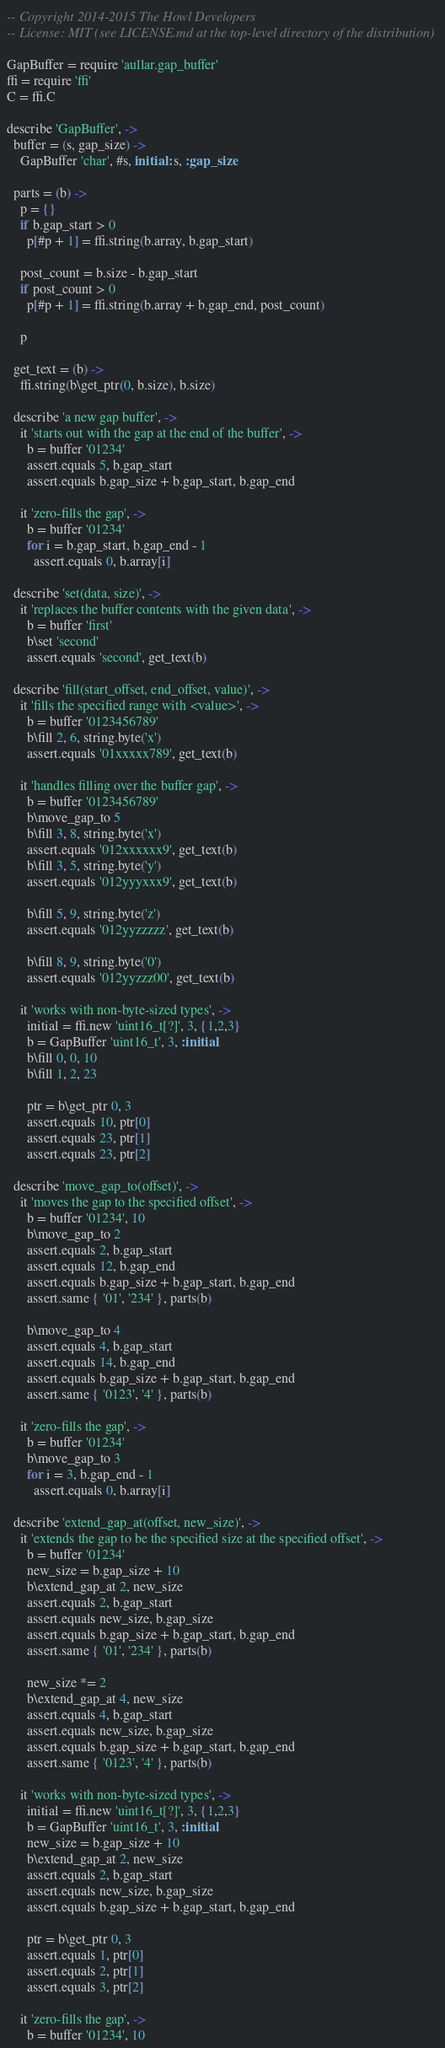<code> <loc_0><loc_0><loc_500><loc_500><_MoonScript_>-- Copyright 2014-2015 The Howl Developers
-- License: MIT (see LICENSE.md at the top-level directory of the distribution)

GapBuffer = require 'aullar.gap_buffer'
ffi = require 'ffi'
C = ffi.C

describe 'GapBuffer', ->
  buffer = (s, gap_size) ->
    GapBuffer 'char', #s, initial: s, :gap_size

  parts = (b) ->
    p = {}
    if b.gap_start > 0
      p[#p + 1] = ffi.string(b.array, b.gap_start)

    post_count = b.size - b.gap_start
    if post_count > 0
      p[#p + 1] = ffi.string(b.array + b.gap_end, post_count)

    p

  get_text = (b) ->
    ffi.string(b\get_ptr(0, b.size), b.size)

  describe 'a new gap buffer', ->
    it 'starts out with the gap at the end of the buffer', ->
      b = buffer '01234'
      assert.equals 5, b.gap_start
      assert.equals b.gap_size + b.gap_start, b.gap_end

    it 'zero-fills the gap', ->
      b = buffer '01234'
      for i = b.gap_start, b.gap_end - 1
        assert.equals 0, b.array[i]

  describe 'set(data, size)', ->
    it 'replaces the buffer contents with the given data', ->
      b = buffer 'first'
      b\set 'second'
      assert.equals 'second', get_text(b)

  describe 'fill(start_offset, end_offset, value)', ->
    it 'fills the specified range with <value>', ->
      b = buffer '0123456789'
      b\fill 2, 6, string.byte('x')
      assert.equals '01xxxxx789', get_text(b)

    it 'handles filling over the buffer gap', ->
      b = buffer '0123456789'
      b\move_gap_to 5
      b\fill 3, 8, string.byte('x')
      assert.equals '012xxxxxx9', get_text(b)
      b\fill 3, 5, string.byte('y')
      assert.equals '012yyyxxx9', get_text(b)

      b\fill 5, 9, string.byte('z')
      assert.equals '012yyzzzzz', get_text(b)

      b\fill 8, 9, string.byte('0')
      assert.equals '012yyzzz00', get_text(b)

    it 'works with non-byte-sized types', ->
      initial = ffi.new 'uint16_t[?]', 3, {1,2,3}
      b = GapBuffer 'uint16_t', 3, :initial
      b\fill 0, 0, 10
      b\fill 1, 2, 23

      ptr = b\get_ptr 0, 3
      assert.equals 10, ptr[0]
      assert.equals 23, ptr[1]
      assert.equals 23, ptr[2]

  describe 'move_gap_to(offset)', ->
    it 'moves the gap to the specified offset', ->
      b = buffer '01234', 10
      b\move_gap_to 2
      assert.equals 2, b.gap_start
      assert.equals 12, b.gap_end
      assert.equals b.gap_size + b.gap_start, b.gap_end
      assert.same { '01', '234' }, parts(b)

      b\move_gap_to 4
      assert.equals 4, b.gap_start
      assert.equals 14, b.gap_end
      assert.equals b.gap_size + b.gap_start, b.gap_end
      assert.same { '0123', '4' }, parts(b)

    it 'zero-fills the gap', ->
      b = buffer '01234'
      b\move_gap_to 3
      for i = 3, b.gap_end - 1
        assert.equals 0, b.array[i]

  describe 'extend_gap_at(offset, new_size)', ->
    it 'extends the gap to be the specified size at the specified offset', ->
      b = buffer '01234'
      new_size = b.gap_size + 10
      b\extend_gap_at 2, new_size
      assert.equals 2, b.gap_start
      assert.equals new_size, b.gap_size
      assert.equals b.gap_size + b.gap_start, b.gap_end
      assert.same { '01', '234' }, parts(b)

      new_size *= 2
      b\extend_gap_at 4, new_size
      assert.equals 4, b.gap_start
      assert.equals new_size, b.gap_size
      assert.equals b.gap_size + b.gap_start, b.gap_end
      assert.same { '0123', '4' }, parts(b)

    it 'works with non-byte-sized types', ->
      initial = ffi.new 'uint16_t[?]', 3, {1,2,3}
      b = GapBuffer 'uint16_t', 3, :initial
      new_size = b.gap_size + 10
      b\extend_gap_at 2, new_size
      assert.equals 2, b.gap_start
      assert.equals new_size, b.gap_size
      assert.equals b.gap_size + b.gap_start, b.gap_end

      ptr = b\get_ptr 0, 3
      assert.equals 1, ptr[0]
      assert.equals 2, ptr[1]
      assert.equals 3, ptr[2]

    it 'zero-fills the gap', ->
      b = buffer '01234', 10</code> 